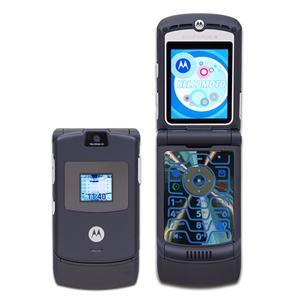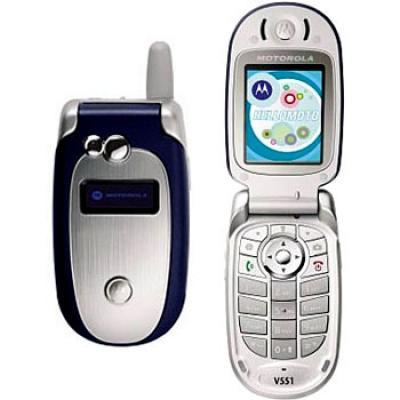The first image is the image on the left, the second image is the image on the right. Assess this claim about the two images: "Each image shows one flip phone in side-by-side open and closed views.". Correct or not? Answer yes or no. Yes. The first image is the image on the left, the second image is the image on the right. Analyze the images presented: Is the assertion "In at least one image there are two phones, one that is open and sliver and the other is closed and blue." valid? Answer yes or no. Yes. 